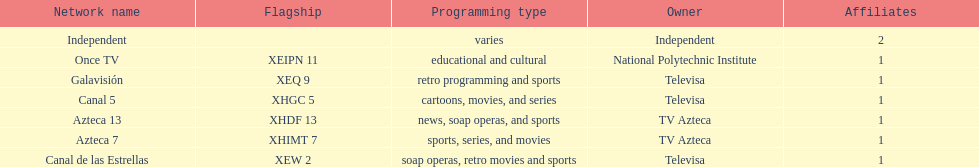Name a station that shows sports but is not televisa. Azteca 7. 